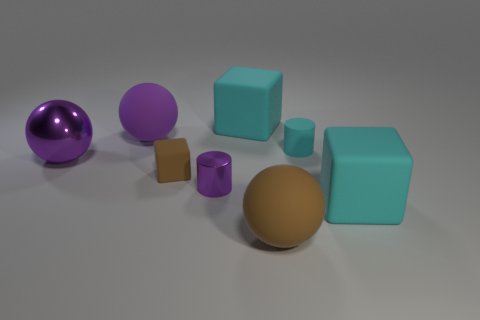Add 1 cyan matte cylinders. How many objects exist? 9 Subtract all cylinders. How many objects are left? 6 Add 5 brown balls. How many brown balls exist? 6 Subtract 0 green blocks. How many objects are left? 8 Subtract all big cyan matte things. Subtract all purple objects. How many objects are left? 3 Add 8 big purple shiny balls. How many big purple shiny balls are left? 9 